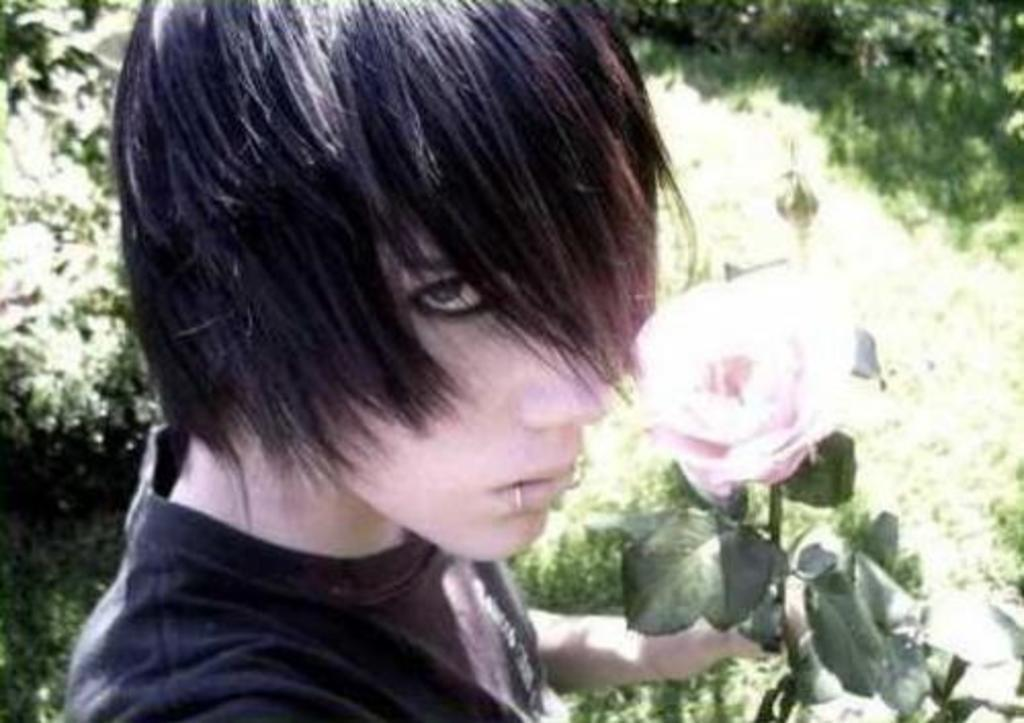Who is the main subject in the image? There is a boy in the center of the image. What is the boy holding in his hand? The boy is holding a rose in his hand. What can be seen in the background of the image? There are trees in the background of the image. What type of ground is visible at the bottom of the image? There is grass at the bottom of the image. Can you see an ant crawling on the boy's arm in the image? There is no ant visible on the boy's arm in the image. Is the boy using a comb to style his hair in the image? There is no comb visible in the image, and the boy's hair is not being styled. 